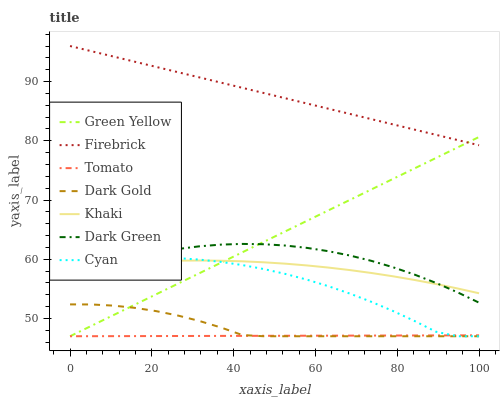Does Khaki have the minimum area under the curve?
Answer yes or no. No. Does Khaki have the maximum area under the curve?
Answer yes or no. No. Is Khaki the smoothest?
Answer yes or no. No. Is Khaki the roughest?
Answer yes or no. No. Does Khaki have the lowest value?
Answer yes or no. No. Does Khaki have the highest value?
Answer yes or no. No. Is Dark Green less than Firebrick?
Answer yes or no. Yes. Is Firebrick greater than Khaki?
Answer yes or no. Yes. Does Dark Green intersect Firebrick?
Answer yes or no. No. 